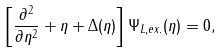<formula> <loc_0><loc_0><loc_500><loc_500>\left [ \frac { \partial ^ { 2 } } { \partial \eta ^ { 2 } } + \eta + \Delta ( \eta ) \right ] \Psi _ { L , e x . } ( \eta ) = 0 ,</formula> 